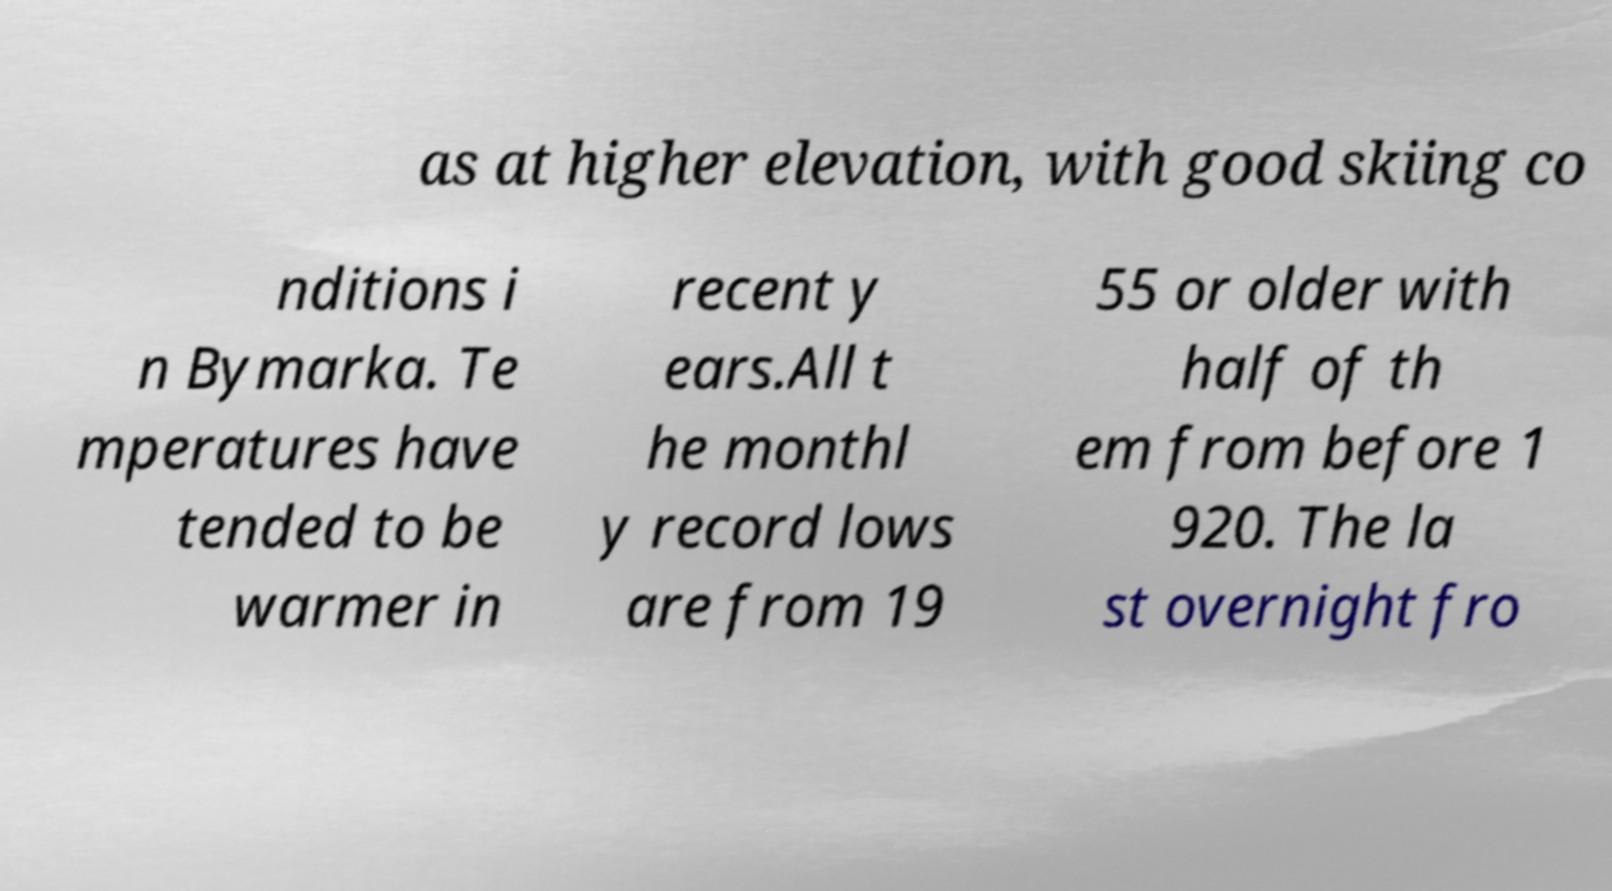I need the written content from this picture converted into text. Can you do that? as at higher elevation, with good skiing co nditions i n Bymarka. Te mperatures have tended to be warmer in recent y ears.All t he monthl y record lows are from 19 55 or older with half of th em from before 1 920. The la st overnight fro 